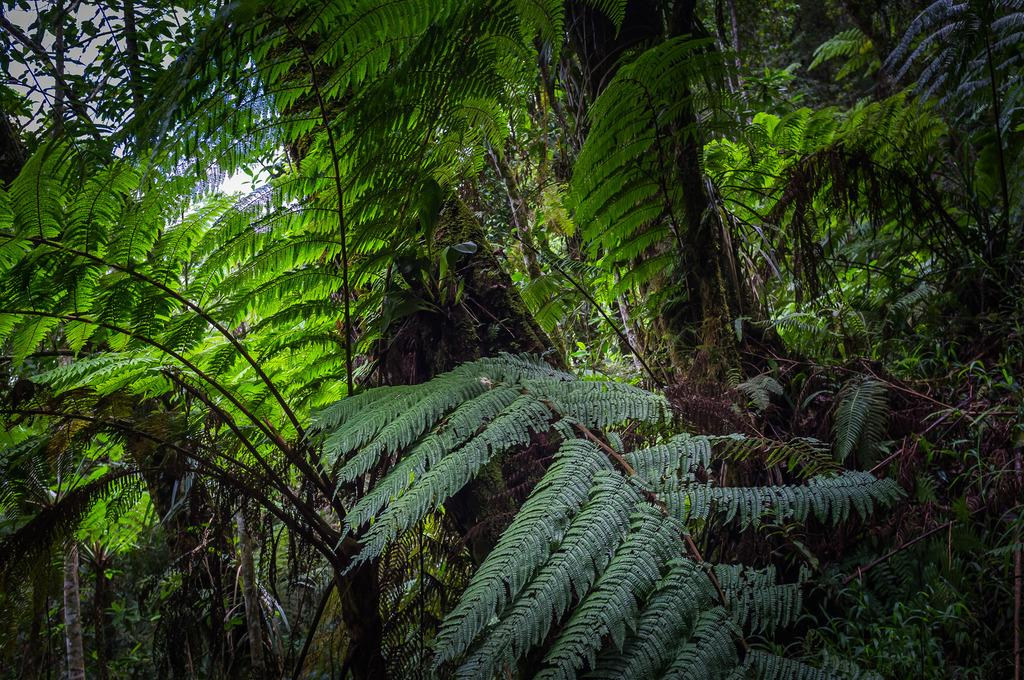What type of vegetation can be seen in the image? There are trees in the image. What is visible at the top of the image? The sky is visible at the top of the image. What can be observed in the sky? There are clouds in the sky. Which actor is performing in the image? There is no actor present in the image; it features trees and clouds in the sky. What type of record can be seen on the ground in the image? There is no record present in the image; it only features trees and clouds in the sky. 